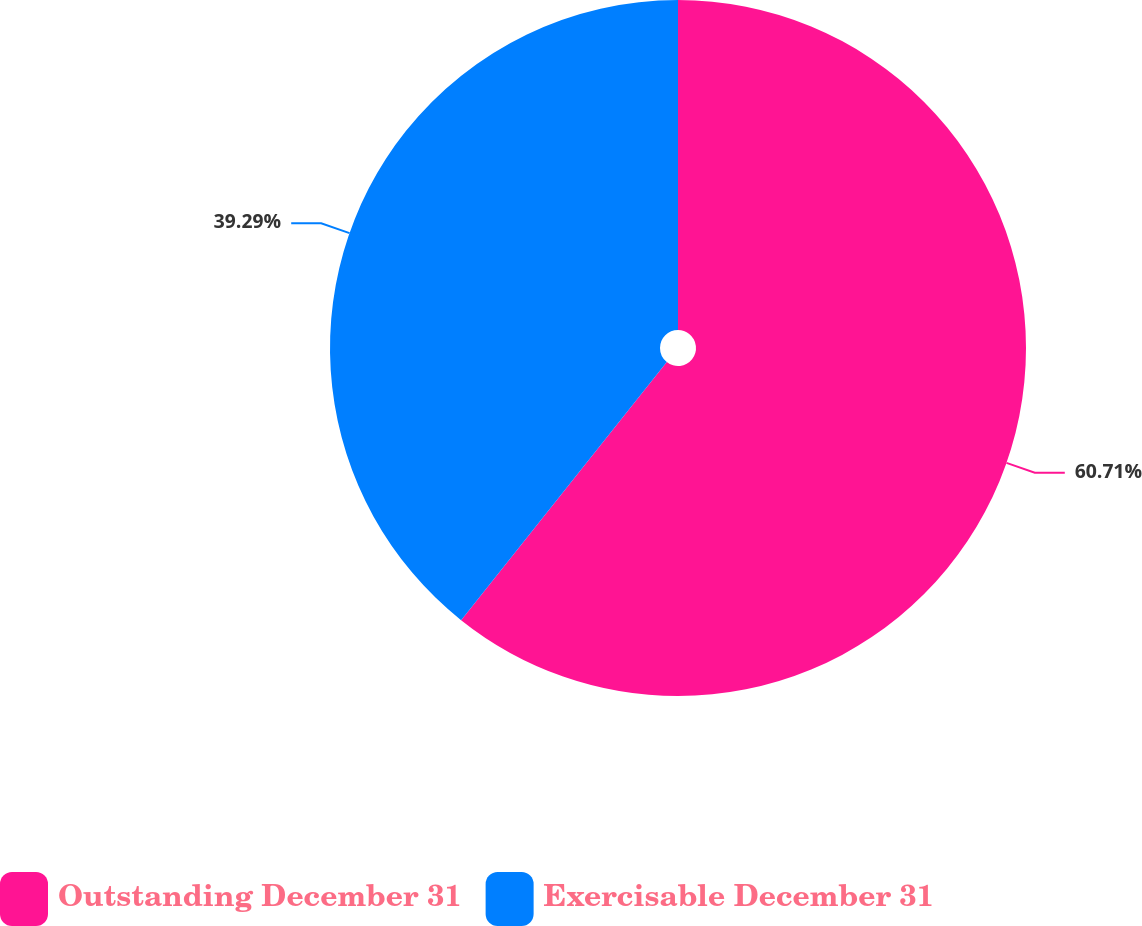<chart> <loc_0><loc_0><loc_500><loc_500><pie_chart><fcel>Outstanding December 31<fcel>Exercisable December 31<nl><fcel>60.71%<fcel>39.29%<nl></chart> 